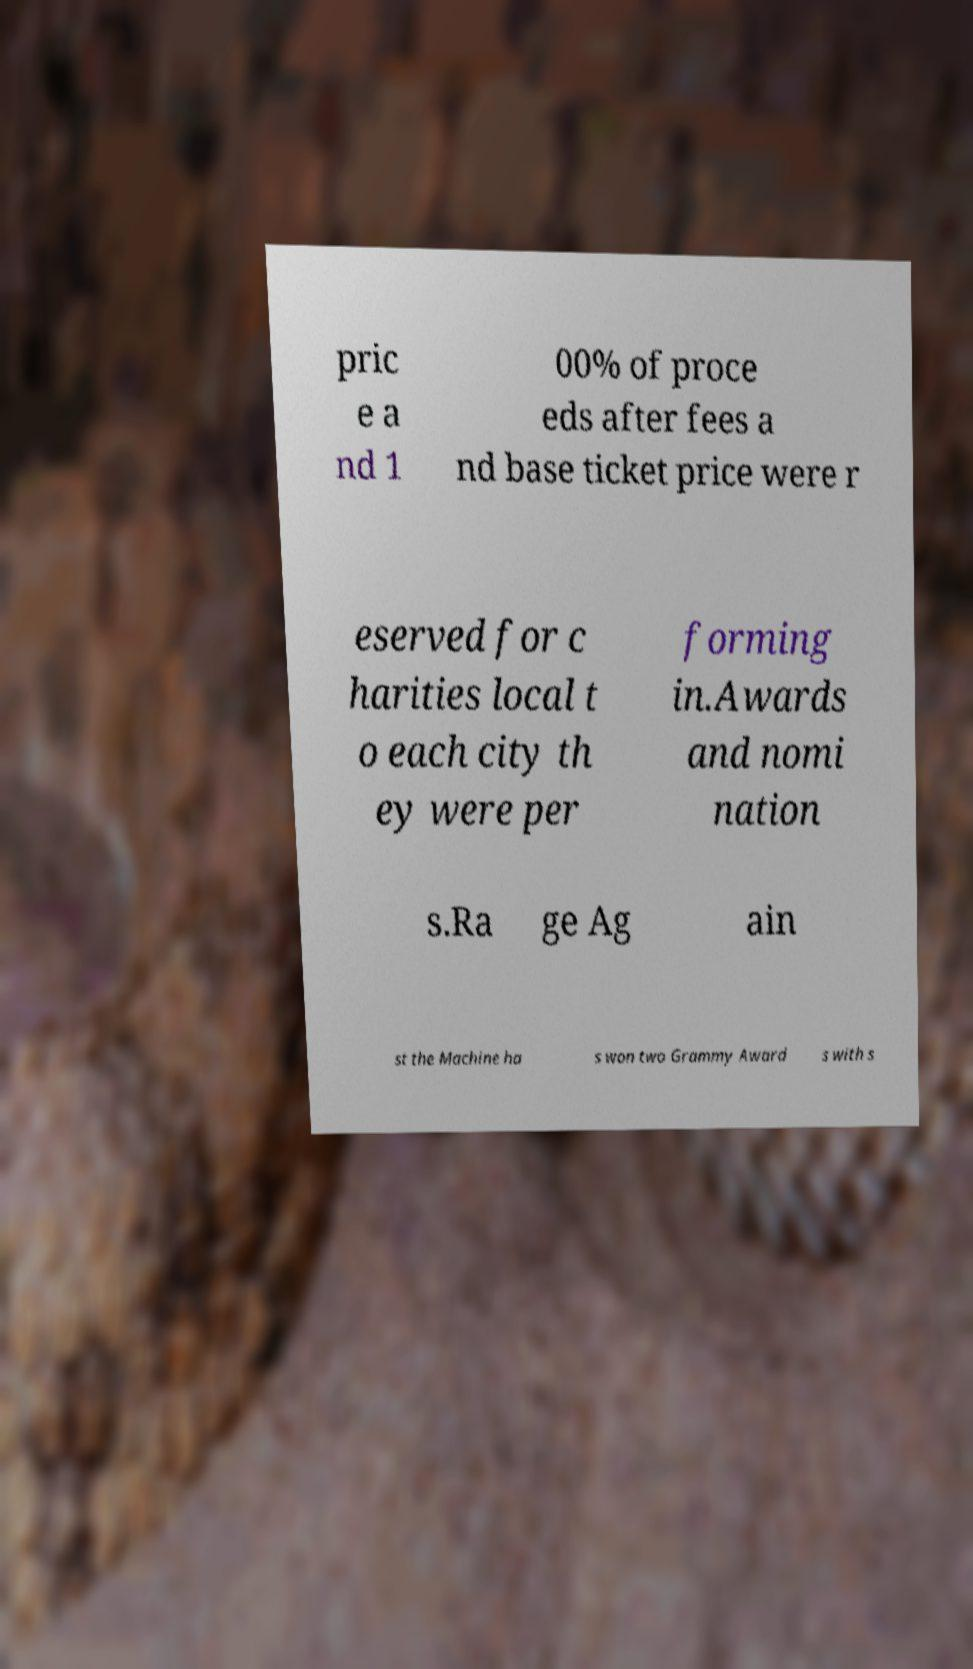There's text embedded in this image that I need extracted. Can you transcribe it verbatim? pric e a nd 1 00% of proce eds after fees a nd base ticket price were r eserved for c harities local t o each city th ey were per forming in.Awards and nomi nation s.Ra ge Ag ain st the Machine ha s won two Grammy Award s with s 